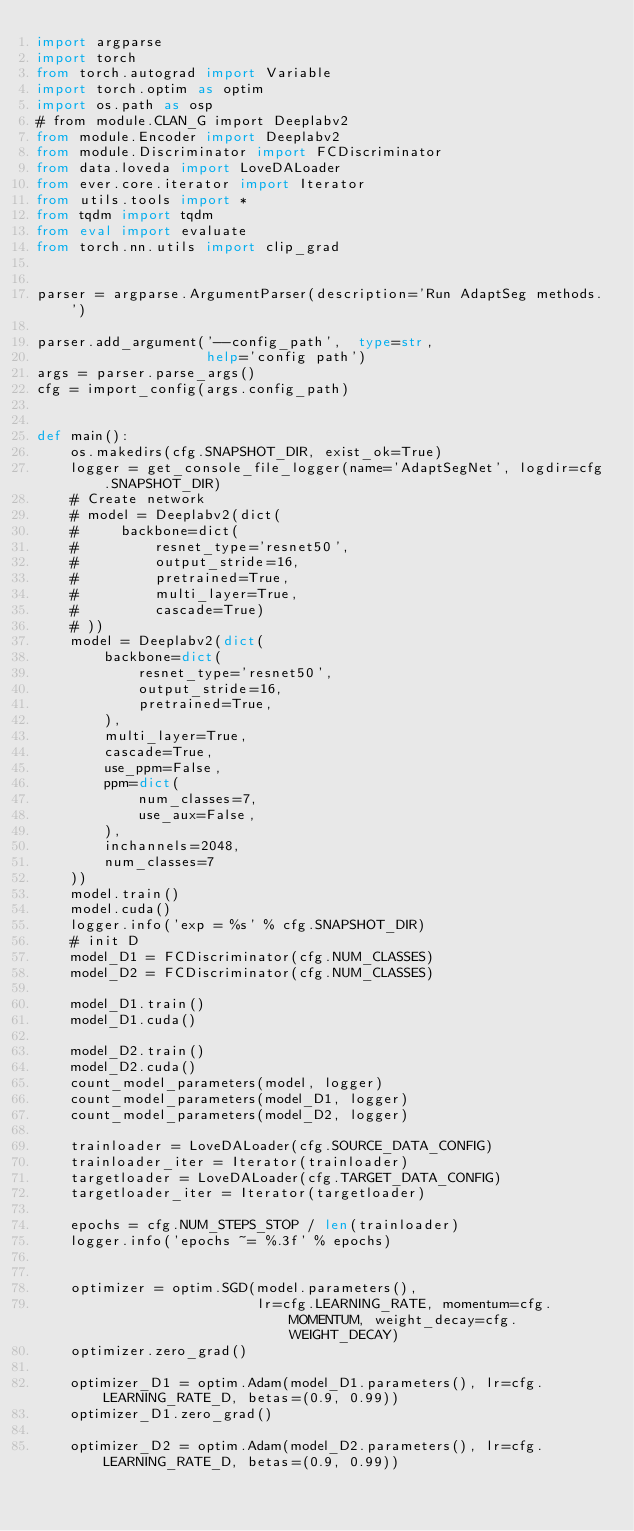<code> <loc_0><loc_0><loc_500><loc_500><_Python_>import argparse
import torch
from torch.autograd import Variable
import torch.optim as optim
import os.path as osp
# from module.CLAN_G import Deeplabv2
from module.Encoder import Deeplabv2
from module.Discriminator import FCDiscriminator
from data.loveda import LoveDALoader
from ever.core.iterator import Iterator
from utils.tools import *
from tqdm import tqdm
from eval import evaluate
from torch.nn.utils import clip_grad


parser = argparse.ArgumentParser(description='Run AdaptSeg methods.')

parser.add_argument('--config_path',  type=str,
                    help='config path')
args = parser.parse_args()
cfg = import_config(args.config_path)


def main():
    os.makedirs(cfg.SNAPSHOT_DIR, exist_ok=True)
    logger = get_console_file_logger(name='AdaptSegNet', logdir=cfg.SNAPSHOT_DIR)
    # Create network
    # model = Deeplabv2(dict(
    #     backbone=dict(
    #         resnet_type='resnet50',
    #         output_stride=16,
    #         pretrained=True,
    #         multi_layer=True,
    #         cascade=True)
    # ))
    model = Deeplabv2(dict(
        backbone=dict(
            resnet_type='resnet50',
            output_stride=16,
            pretrained=True,
        ),
        multi_layer=True,
        cascade=True,
        use_ppm=False,
        ppm=dict(
            num_classes=7,
            use_aux=False,
        ),
        inchannels=2048,
        num_classes=7
    ))
    model.train()
    model.cuda()
    logger.info('exp = %s' % cfg.SNAPSHOT_DIR)
    # init D
    model_D1 = FCDiscriminator(cfg.NUM_CLASSES)
    model_D2 = FCDiscriminator(cfg.NUM_CLASSES)

    model_D1.train()
    model_D1.cuda()

    model_D2.train()
    model_D2.cuda()
    count_model_parameters(model, logger)
    count_model_parameters(model_D1, logger)
    count_model_parameters(model_D2, logger)

    trainloader = LoveDALoader(cfg.SOURCE_DATA_CONFIG)
    trainloader_iter = Iterator(trainloader)
    targetloader = LoveDALoader(cfg.TARGET_DATA_CONFIG)
    targetloader_iter = Iterator(targetloader)

    epochs = cfg.NUM_STEPS_STOP / len(trainloader)
    logger.info('epochs ~= %.3f' % epochs)


    optimizer = optim.SGD(model.parameters(),
                          lr=cfg.LEARNING_RATE, momentum=cfg.MOMENTUM, weight_decay=cfg.WEIGHT_DECAY)
    optimizer.zero_grad()

    optimizer_D1 = optim.Adam(model_D1.parameters(), lr=cfg.LEARNING_RATE_D, betas=(0.9, 0.99))
    optimizer_D1.zero_grad()

    optimizer_D2 = optim.Adam(model_D2.parameters(), lr=cfg.LEARNING_RATE_D, betas=(0.9, 0.99))</code> 